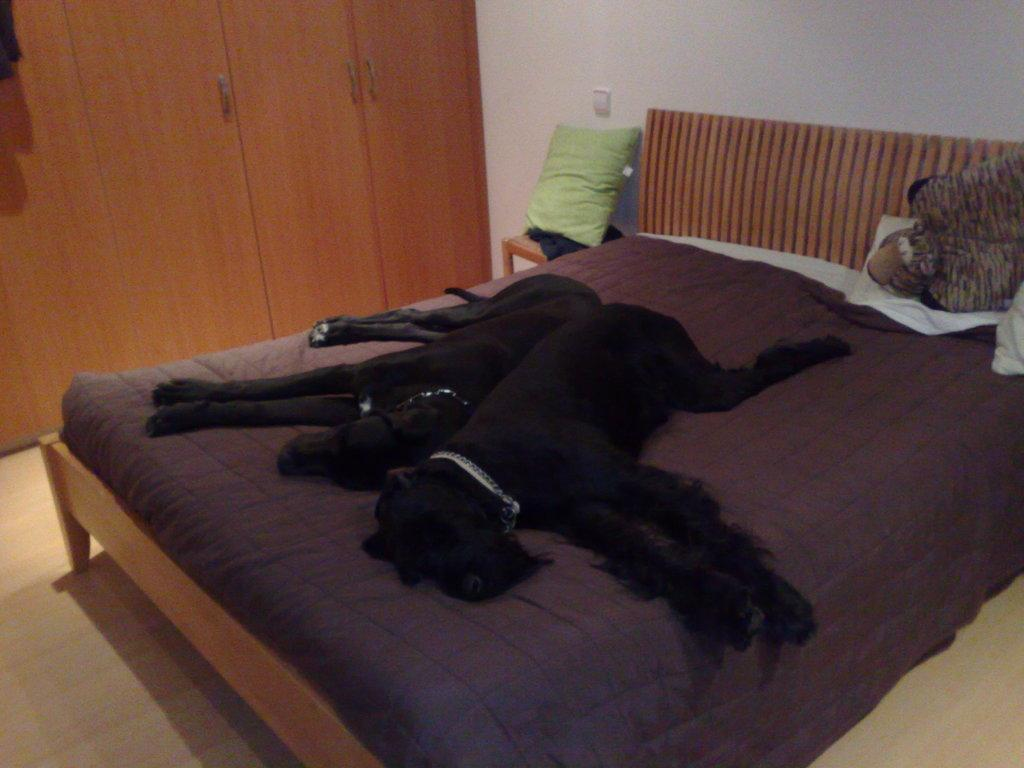How many dogs are in the image? There are 2 black dogs in the image. What are the dogs doing in the image? The dogs are sleeping on a bed. What can be seen in the background of the image? In the background, there is a pillow, a wall, a switch board, and a wooden cupboard. What type of market can be seen in the image? There is no market present in the image. What is the relation between the dogs and the wooden cupboard in the image? The provided facts do not give any information about the relationship between the dogs and the wooden cupboard. 